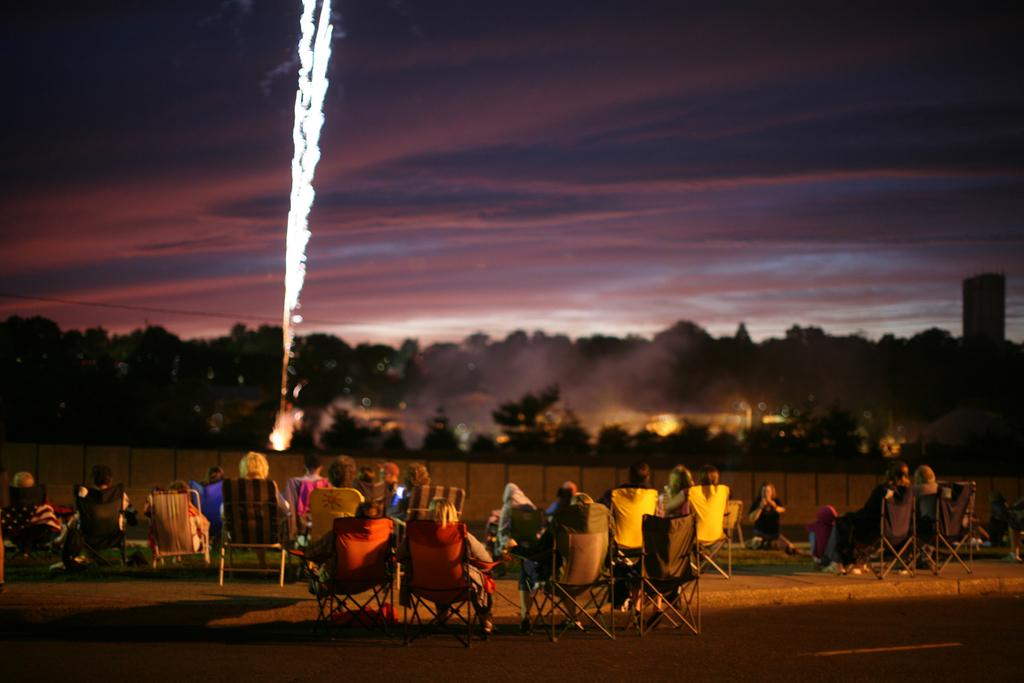What are the people in the image doing? The people in the image are sitting at the bottom. What is in front of the people? There are trees and fireworks in front of the people. What can be seen in the sky at the top of the image? There are clouds in the sky at the top of the image. What type of grass is being used to create the fireworks in the image? There is no grass being used to create the fireworks in the image; the fireworks are likely made of other materials. 